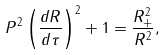Convert formula to latex. <formula><loc_0><loc_0><loc_500><loc_500>P ^ { 2 } \left ( \frac { d R } { d \tau } \right ) ^ { 2 } + 1 = \frac { R _ { + } ^ { 2 } } { R ^ { 2 } } ,</formula> 